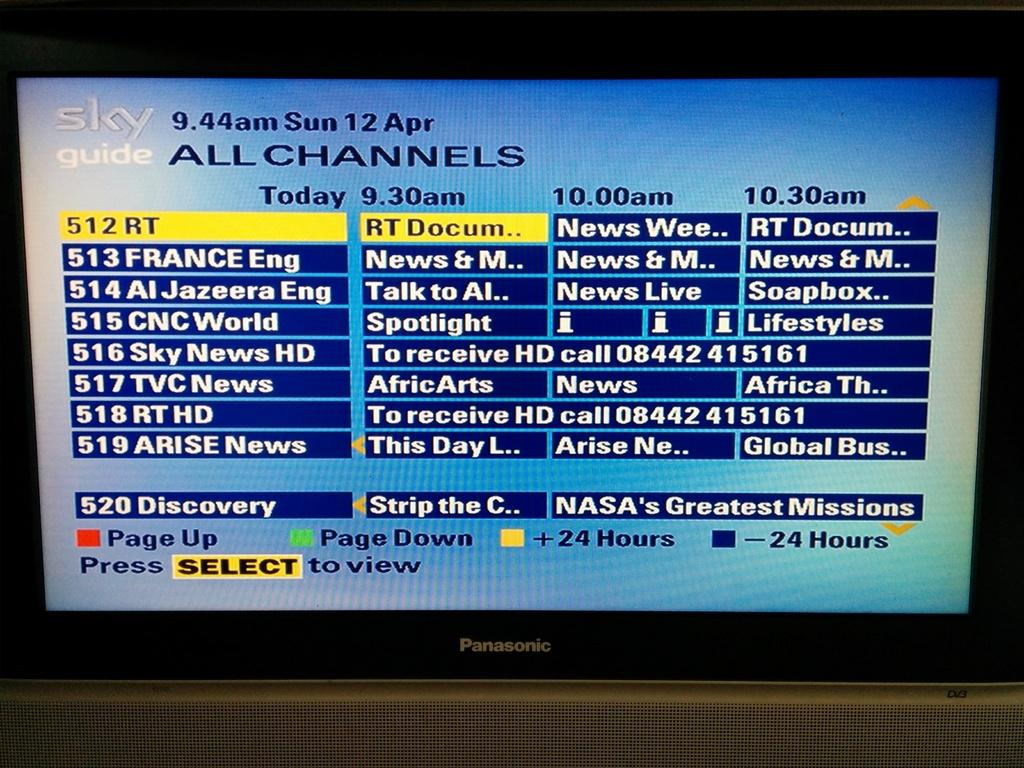<image>
Give a short and clear explanation of the subsequent image. The time on the channel is 944 am on april 12th 